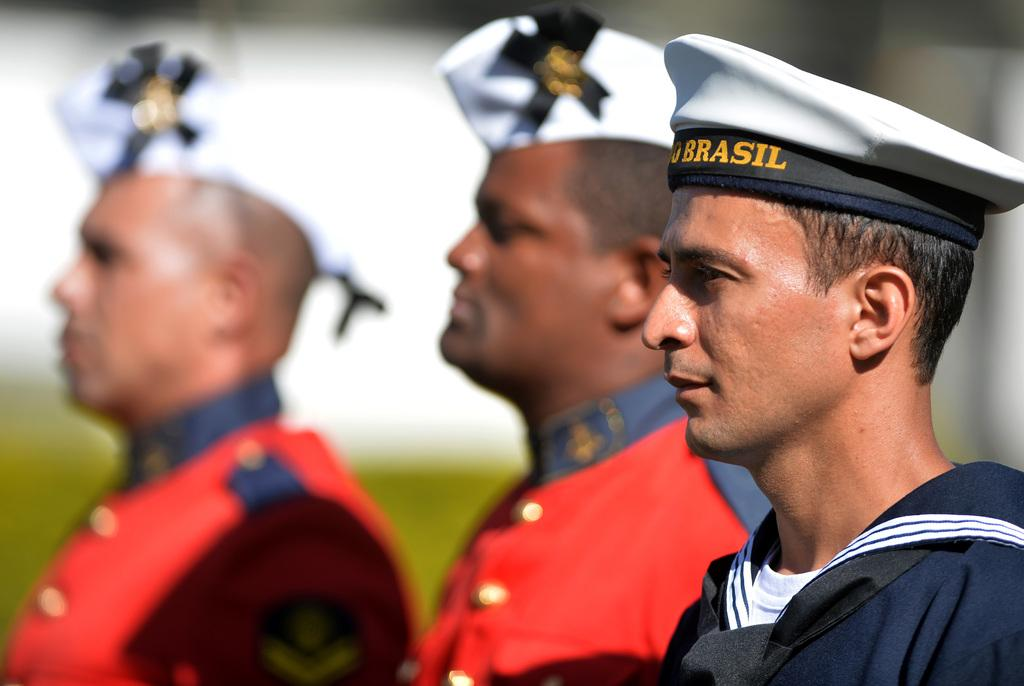How many persons are in the image? There are three persons in the image. Where are the persons located in the image? The three persons are standing in the middle of the image. What are the persons wearing on their heads? The persons are wearing white color caps. What type of news can be heard coming from the persons in the image? There is no indication in the image that the persons are discussing or sharing any news. How are the persons using the basket in the image? There is no basket present in the image. 